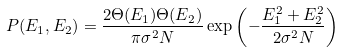<formula> <loc_0><loc_0><loc_500><loc_500>P ( E _ { 1 } , E _ { 2 } ) = \frac { 2 \Theta ( E _ { 1 } ) \Theta ( E _ { 2 } ) } { \pi \sigma ^ { 2 } N } \exp { \left ( - \frac { E _ { 1 } ^ { 2 } + E _ { 2 } ^ { 2 } } { 2 \sigma ^ { 2 } N } \right ) }</formula> 